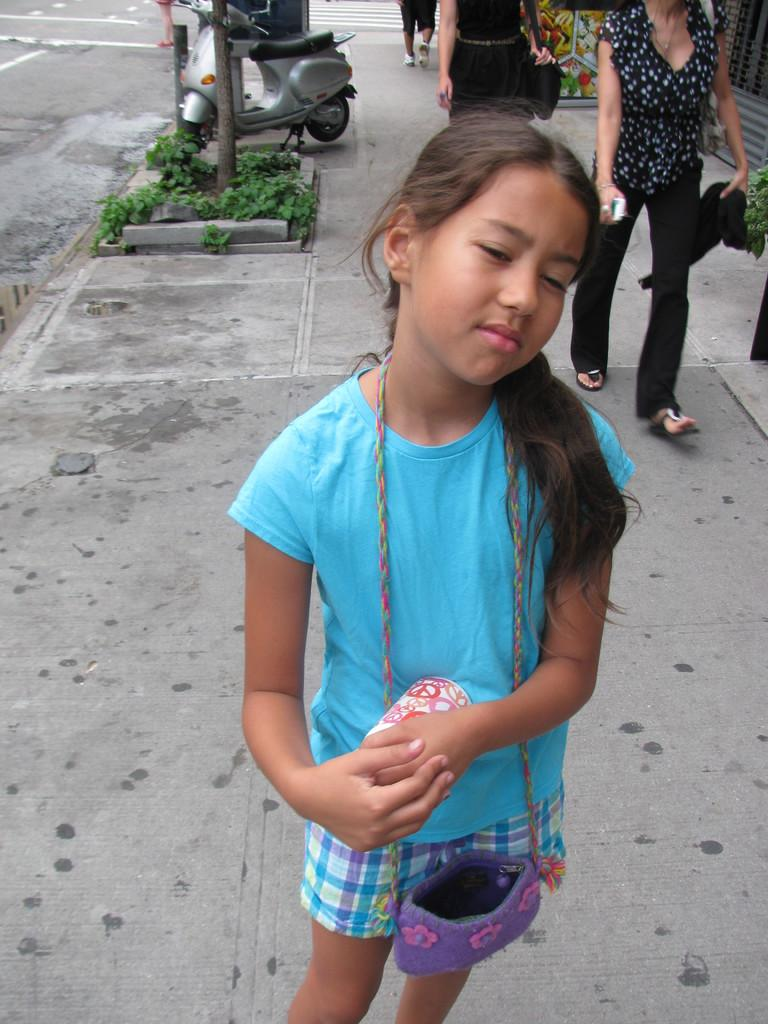What is the girl in the image doing? The girl in the image is standing and carrying her bag. What are the two persons in the image doing? The two persons in the image are walking on the sidewalk. What type of vegetation can be seen in the image? There are plants visible in the image. What mode of transportation is present in the image? There is a scooter in the image. What type of surface is visible in the image? There is a road in the image. What type of creature is sitting on the girl's shoulder in the image? There is no creature visible on the girl's shoulder in the image. Does the girl have an umbrella to protect her from the rain in the image? There is no mention of rain or an umbrella in the image. 